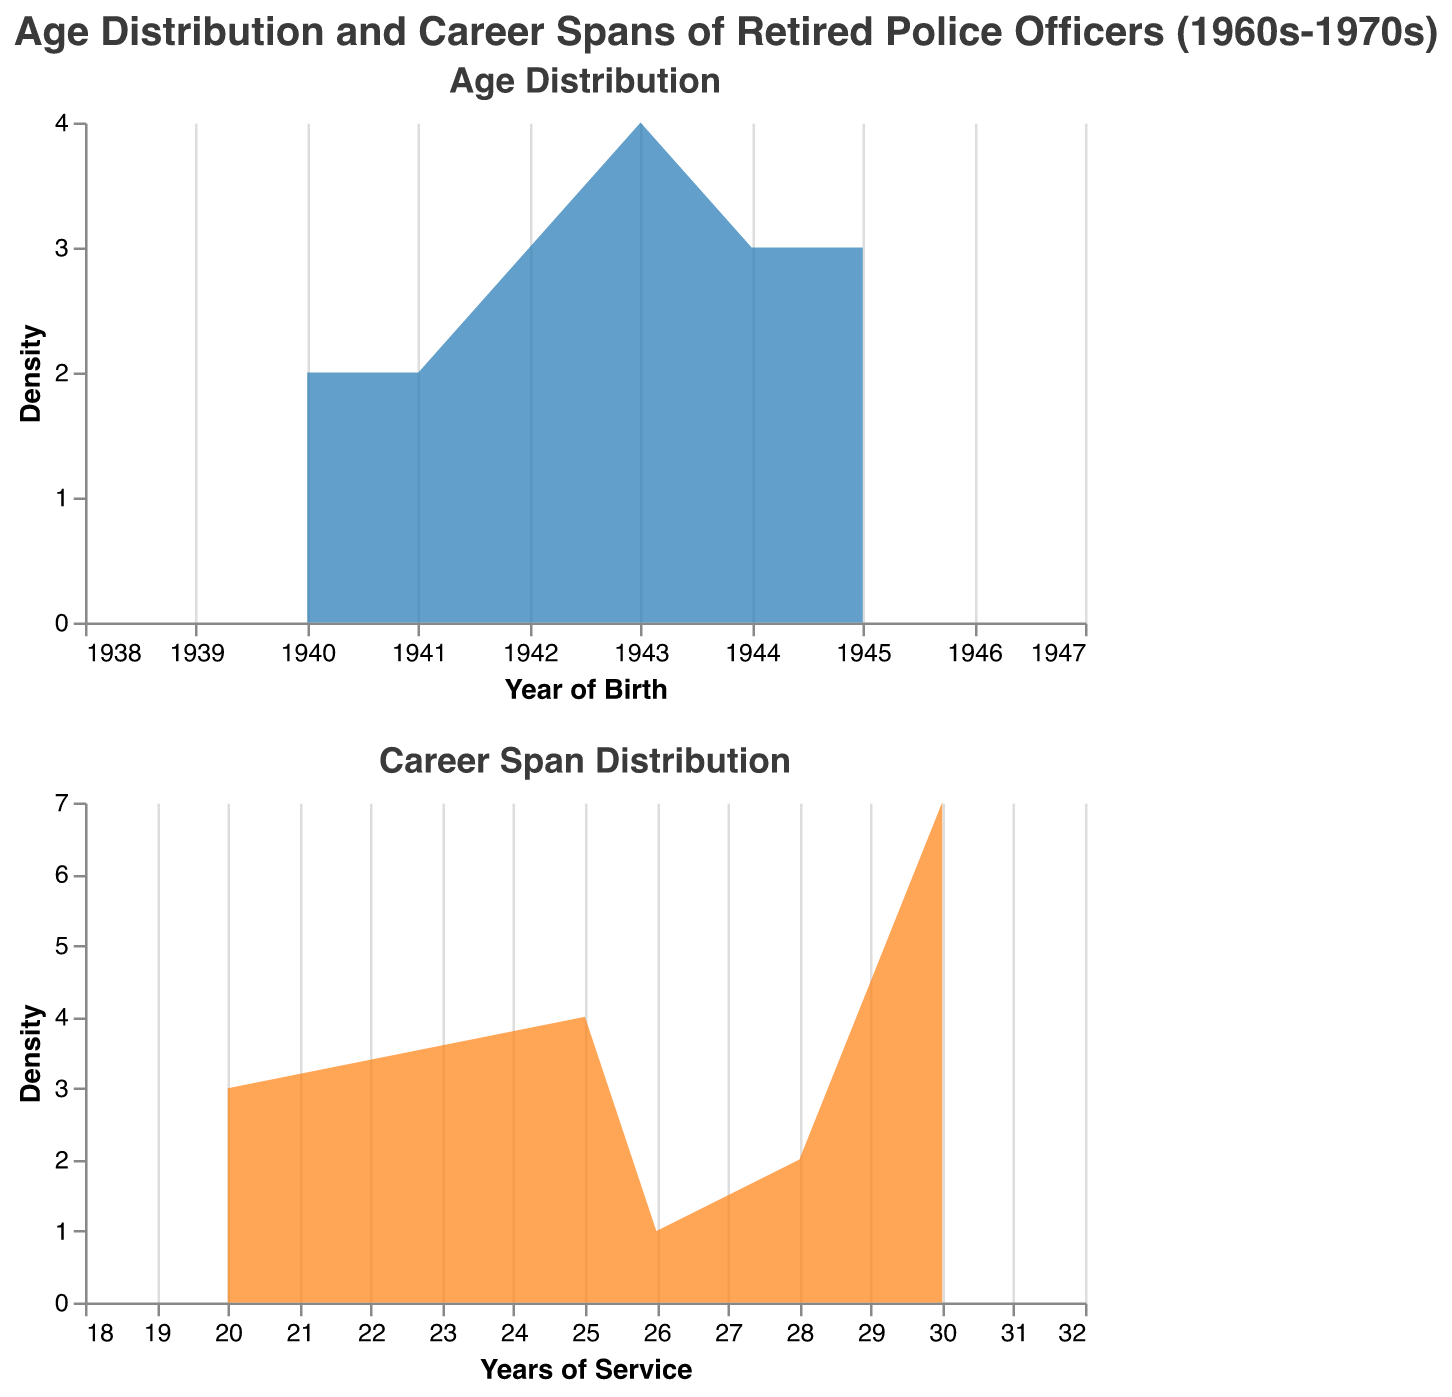What's the title of the figure? The title is displayed at the top, which reads "Age Distribution and Career Spans of Retired Police Officers (1960s-1970s)."
Answer: Age Distribution and Career Spans of Retired Police Officers (1960s-1970s) What is the most common year of birth for retired police officers? The first plot shows the year of birth on the x-axis and the density on the y-axis. The peak of this density plot represents the most common year of birth.
Answer: 1943 Which age group (year of birth) has the highest density in the age distribution plot? By looking at the peak of the first density plot, the highest density occurs for those born around 1943.
Answer: 1943 Compare the highest density between the age distribution and career span distribution. Which one is higher? The density axis in both plots represents the count of individuals. By comparing the peaks visually, the age distribution (first plot) has a higher peak than the career span distribution (second plot).
Answer: Age distribution What is the range of years of service shown in the second plot? The x-axis of the second plot shows the range of years of service, which is given between 18 and 32 years.
Answer: 18 to 32 years How many data points were used to generate these plots? There are 17 names listed in the data, indicating 17 data points were used for the analysis.
Answer: 17 What is the main observation from the career span distribution plot? The main observation is that the density peaks around 30 years of service, implying that a significant number of officers served for approximately 30 years.
Answer: Peaks around 30 years of service Between which years were the majority of the officers born based on the first plot? The majority of the officers were born between 1940 and 1945, as the plot shows a higher density in that range.
Answer: 1940 to 1945 How does the career span distribution suggest the typical tenure of a retired officer during this period? The second plot indicates that a typical tenure is around 25 to 30 years, with the highest density observed in this range.
Answer: Around 25 to 30 years 